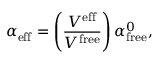Convert formula to latex. <formula><loc_0><loc_0><loc_500><loc_500>\alpha _ { e f f } = \left ( \frac { V ^ { e f f } } { V ^ { f r e e } } \right ) \alpha _ { f r e e } ^ { 0 } ,</formula> 